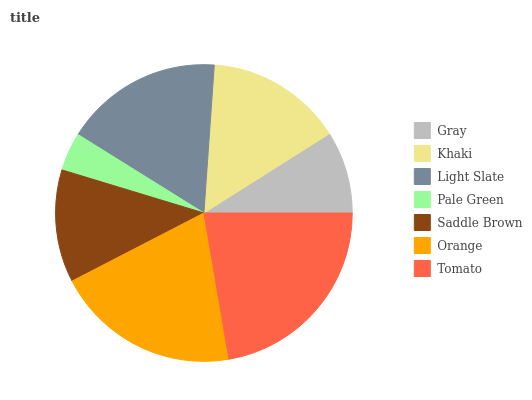Is Pale Green the minimum?
Answer yes or no. Yes. Is Tomato the maximum?
Answer yes or no. Yes. Is Khaki the minimum?
Answer yes or no. No. Is Khaki the maximum?
Answer yes or no. No. Is Khaki greater than Gray?
Answer yes or no. Yes. Is Gray less than Khaki?
Answer yes or no. Yes. Is Gray greater than Khaki?
Answer yes or no. No. Is Khaki less than Gray?
Answer yes or no. No. Is Khaki the high median?
Answer yes or no. Yes. Is Khaki the low median?
Answer yes or no. Yes. Is Pale Green the high median?
Answer yes or no. No. Is Pale Green the low median?
Answer yes or no. No. 